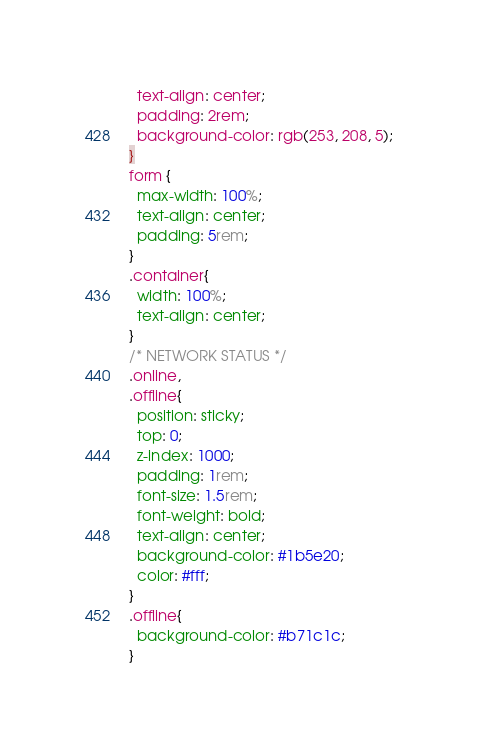Convert code to text. <code><loc_0><loc_0><loc_500><loc_500><_CSS_>  text-align: center;
  padding: 2rem;
  background-color: rgb(253, 208, 5);
}
form {
  max-width: 100%;
  text-align: center;
  padding: 5rem;
}
.container{
  width: 100%;
  text-align: center;
}
/* NETWORK STATUS */
.online,
.offline{
  position: sticky;
  top: 0;
  z-index: 1000;
  padding: 1rem;
  font-size: 1.5rem;
  font-weight: bold;
  text-align: center;
  background-color: #1b5e20;
  color: #fff;
}
.offline{
  background-color: #b71c1c;
}
</code> 